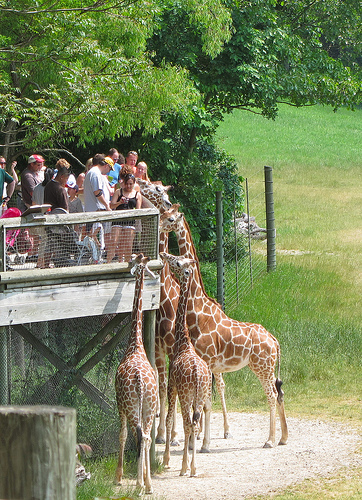Is there any significance to the patterns on a giraffe's coat? Yes, the patterns on a giraffe's coat, which are unique to each individual, help with camouflage in their natural habitat. The various shapes and shades of the patches can also serve as a thermal regulator and could potentially be used for identification among the giraffes themselves. 